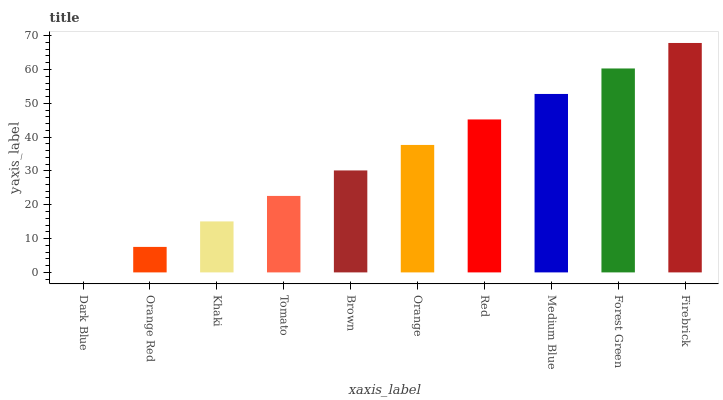Is Dark Blue the minimum?
Answer yes or no. Yes. Is Firebrick the maximum?
Answer yes or no. Yes. Is Orange Red the minimum?
Answer yes or no. No. Is Orange Red the maximum?
Answer yes or no. No. Is Orange Red greater than Dark Blue?
Answer yes or no. Yes. Is Dark Blue less than Orange Red?
Answer yes or no. Yes. Is Dark Blue greater than Orange Red?
Answer yes or no. No. Is Orange Red less than Dark Blue?
Answer yes or no. No. Is Orange the high median?
Answer yes or no. Yes. Is Brown the low median?
Answer yes or no. Yes. Is Forest Green the high median?
Answer yes or no. No. Is Firebrick the low median?
Answer yes or no. No. 